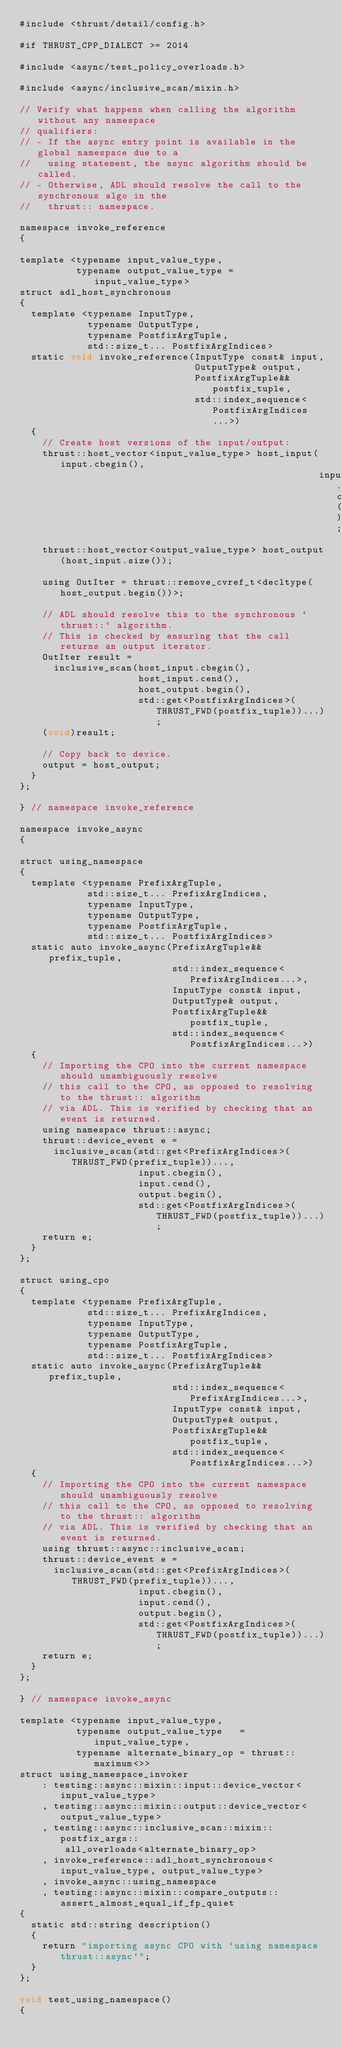<code> <loc_0><loc_0><loc_500><loc_500><_Cuda_>#include <thrust/detail/config.h>

#if THRUST_CPP_DIALECT >= 2014

#include <async/test_policy_overloads.h>

#include <async/inclusive_scan/mixin.h>

// Verify what happens when calling the algorithm without any namespace
// qualifiers:
// - If the async entry point is available in the global namespace due to a
//   using statement, the async algorithm should be called.
// - Otherwise, ADL should resolve the call to the synchronous algo in the
//   thrust:: namespace.

namespace invoke_reference
{

template <typename input_value_type,
          typename output_value_type = input_value_type>
struct adl_host_synchronous
{
  template <typename InputType,
            typename OutputType,
            typename PostfixArgTuple,
            std::size_t... PostfixArgIndices>
  static void invoke_reference(InputType const& input,
                               OutputType& output,
                               PostfixArgTuple&& postfix_tuple,
                               std::index_sequence<PostfixArgIndices...>)
  {
    // Create host versions of the input/output:
    thrust::host_vector<input_value_type> host_input(input.cbegin(),
                                                     input.cend());
    thrust::host_vector<output_value_type> host_output(host_input.size());

    using OutIter = thrust::remove_cvref_t<decltype(host_output.begin())>;

    // ADL should resolve this to the synchronous `thrust::` algorithm.
    // This is checked by ensuring that the call returns an output iterator.
    OutIter result =
      inclusive_scan(host_input.cbegin(),
                     host_input.cend(),
                     host_output.begin(),
                     std::get<PostfixArgIndices>(THRUST_FWD(postfix_tuple))...);
    (void)result;

    // Copy back to device.
    output = host_output;
  }
};

} // namespace invoke_reference

namespace invoke_async
{

struct using_namespace
{
  template <typename PrefixArgTuple,
            std::size_t... PrefixArgIndices,
            typename InputType,
            typename OutputType,
            typename PostfixArgTuple,
            std::size_t... PostfixArgIndices>
  static auto invoke_async(PrefixArgTuple&& prefix_tuple,
                           std::index_sequence<PrefixArgIndices...>,
                           InputType const& input,
                           OutputType& output,
                           PostfixArgTuple&& postfix_tuple,
                           std::index_sequence<PostfixArgIndices...>)
  {
    // Importing the CPO into the current namespace should unambiguously resolve
    // this call to the CPO, as opposed to resolving to the thrust:: algorithm
    // via ADL. This is verified by checking that an event is returned.
    using namespace thrust::async;
    thrust::device_event e =
      inclusive_scan(std::get<PrefixArgIndices>(THRUST_FWD(prefix_tuple))...,
                     input.cbegin(),
                     input.cend(),
                     output.begin(),
                     std::get<PostfixArgIndices>(THRUST_FWD(postfix_tuple))...);
    return e;
  }
};

struct using_cpo
{
  template <typename PrefixArgTuple,
            std::size_t... PrefixArgIndices,
            typename InputType,
            typename OutputType,
            typename PostfixArgTuple,
            std::size_t... PostfixArgIndices>
  static auto invoke_async(PrefixArgTuple&& prefix_tuple,
                           std::index_sequence<PrefixArgIndices...>,
                           InputType const& input,
                           OutputType& output,
                           PostfixArgTuple&& postfix_tuple,
                           std::index_sequence<PostfixArgIndices...>)
  {
    // Importing the CPO into the current namespace should unambiguously resolve
    // this call to the CPO, as opposed to resolving to the thrust:: algorithm
    // via ADL. This is verified by checking that an event is returned.
    using thrust::async::inclusive_scan;
    thrust::device_event e =
      inclusive_scan(std::get<PrefixArgIndices>(THRUST_FWD(prefix_tuple))...,
                     input.cbegin(),
                     input.cend(),
                     output.begin(),
                     std::get<PostfixArgIndices>(THRUST_FWD(postfix_tuple))...);
    return e;
  }
};

} // namespace invoke_async

template <typename input_value_type,
          typename output_value_type   = input_value_type,
          typename alternate_binary_op = thrust::maximum<>>
struct using_namespace_invoker
    : testing::async::mixin::input::device_vector<input_value_type>
    , testing::async::mixin::output::device_vector<output_value_type>
    , testing::async::inclusive_scan::mixin::postfix_args::
        all_overloads<alternate_binary_op>
    , invoke_reference::adl_host_synchronous<input_value_type, output_value_type>
    , invoke_async::using_namespace
    , testing::async::mixin::compare_outputs::assert_almost_equal_if_fp_quiet
{
  static std::string description()
  {
    return "importing async CPO with `using namespace thrust::async`";
  }
};

void test_using_namespace()
{</code> 